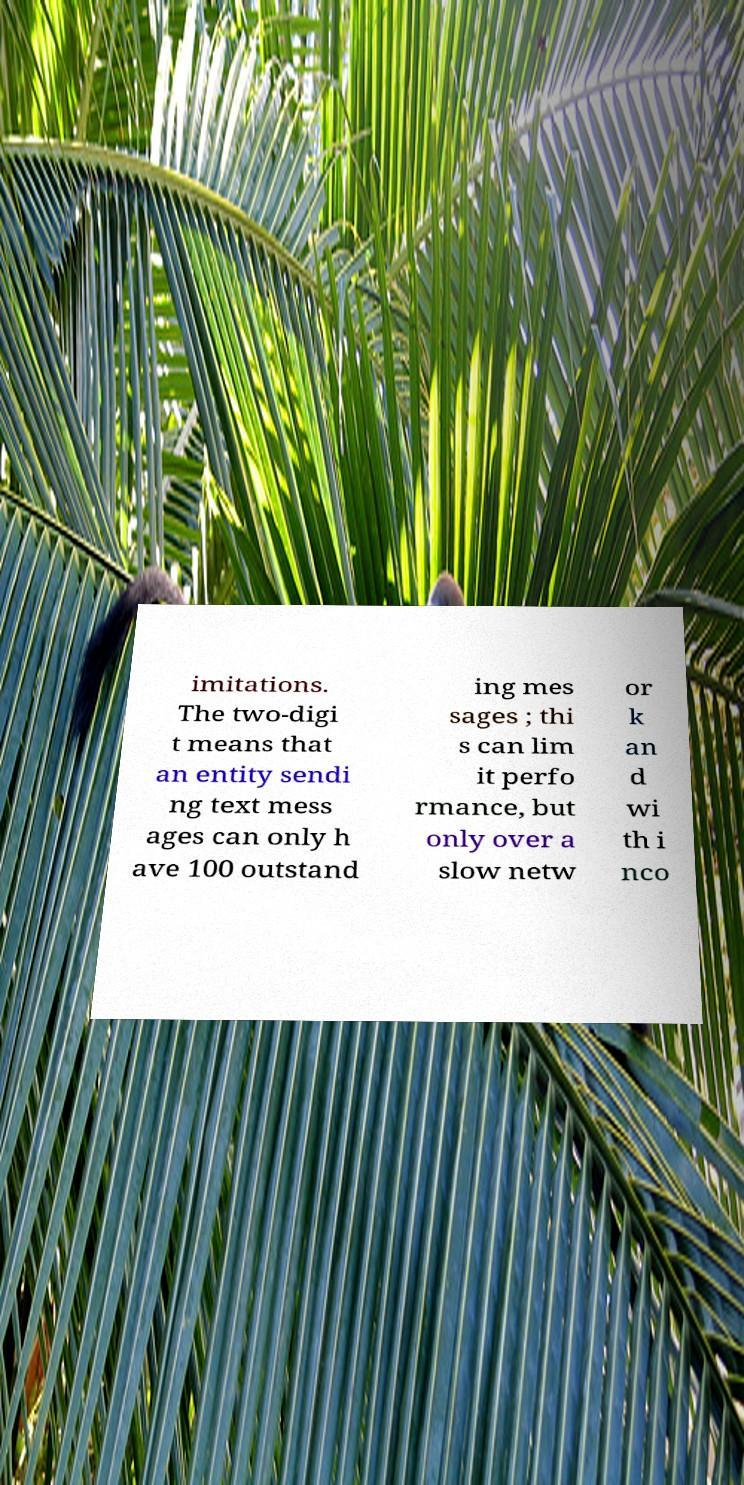Could you extract and type out the text from this image? imitations. The two-digi t means that an entity sendi ng text mess ages can only h ave 100 outstand ing mes sages ; thi s can lim it perfo rmance, but only over a slow netw or k an d wi th i nco 